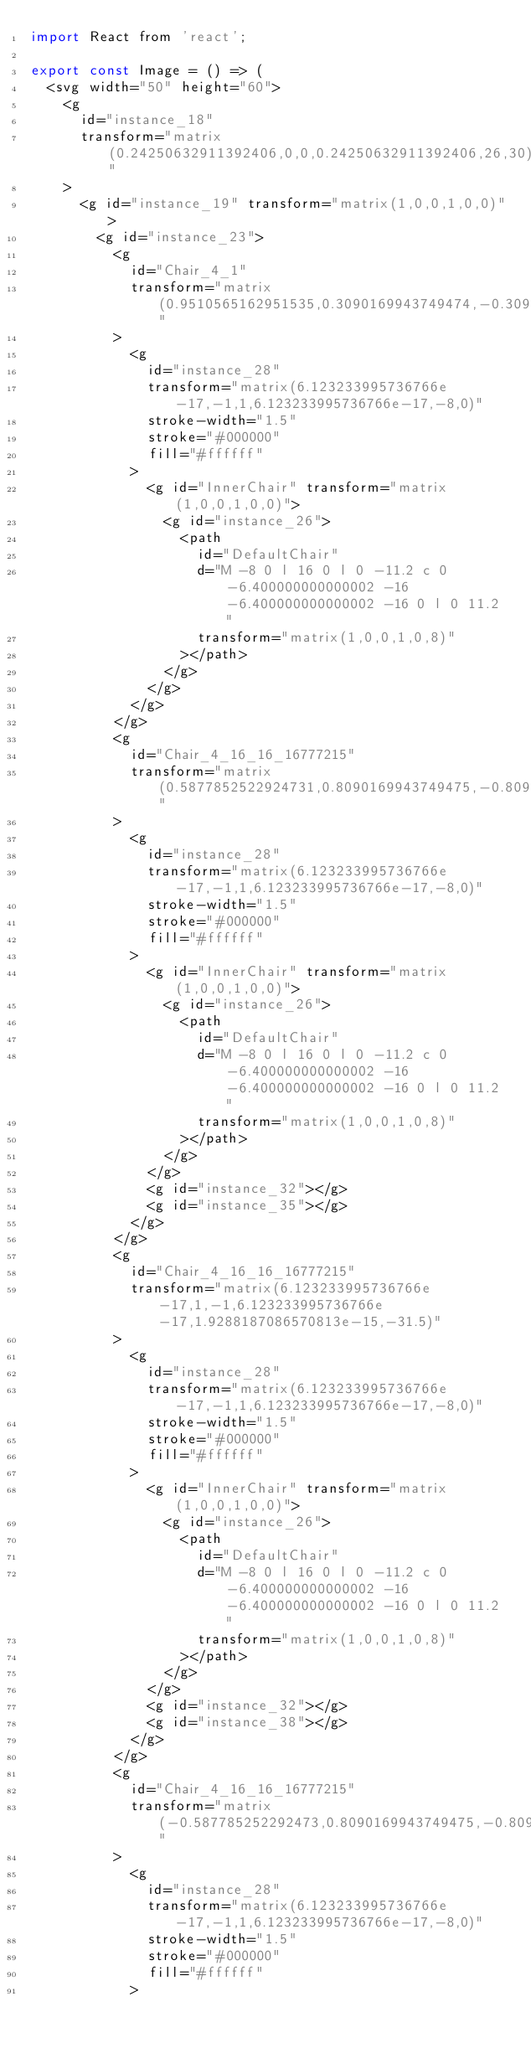Convert code to text. <code><loc_0><loc_0><loc_500><loc_500><_JavaScript_>import React from 'react';

export const Image = () => (
  <svg width="50" height="60">
    <g
      id="instance_18"
      transform="matrix(0.24250632911392406,0,0,0.24250632911392406,26,30)"
    >
      <g id="instance_19" transform="matrix(1,0,0,1,0,0)">
        <g id="instance_23">
          <g
            id="Chair_4_1"
            transform="matrix(0.9510565162951535,0.3090169943749474,-0.3090169943749474,0.9510565162951535,-29.958280263297336,-9.734035322810847)"
          >
            <g
              id="instance_28"
              transform="matrix(6.123233995736766e-17,-1,1,6.123233995736766e-17,-8,0)"
              stroke-width="1.5"
              stroke="#000000"
              fill="#ffffff"
            >
              <g id="InnerChair" transform="matrix(1,0,0,1,0,0)">
                <g id="instance_26">
                  <path
                    id="DefaultChair"
                    d="M -8 0 l 16 0 l 0 -11.2 c 0 -6.400000000000002 -16 -6.400000000000002 -16 0 l 0 11.2 "
                    transform="matrix(1,0,0,1,0,8)"
                  ></path>
                </g>
              </g>
            </g>
          </g>
          <g
            id="Chair_4_16_16_16777215"
            transform="matrix(0.5877852522924731,0.8090169943749475,-0.8090169943749475,0.5877852522924731,-18.515235447212902,-25.484035322810843)"
          >
            <g
              id="instance_28"
              transform="matrix(6.123233995736766e-17,-1,1,6.123233995736766e-17,-8,0)"
              stroke-width="1.5"
              stroke="#000000"
              fill="#ffffff"
            >
              <g id="InnerChair" transform="matrix(1,0,0,1,0,0)">
                <g id="instance_26">
                  <path
                    id="DefaultChair"
                    d="M -8 0 l 16 0 l 0 -11.2 c 0 -6.400000000000002 -16 -6.400000000000002 -16 0 l 0 11.2 "
                    transform="matrix(1,0,0,1,0,8)"
                  ></path>
                </g>
              </g>
              <g id="instance_32"></g>
              <g id="instance_35"></g>
            </g>
          </g>
          <g
            id="Chair_4_16_16_16777215"
            transform="matrix(6.123233995736766e-17,1,-1,6.123233995736766e-17,1.9288187086570813e-15,-31.5)"
          >
            <g
              id="instance_28"
              transform="matrix(6.123233995736766e-17,-1,1,6.123233995736766e-17,-8,0)"
              stroke-width="1.5"
              stroke="#000000"
              fill="#ffffff"
            >
              <g id="InnerChair" transform="matrix(1,0,0,1,0,0)">
                <g id="instance_26">
                  <path
                    id="DefaultChair"
                    d="M -8 0 l 16 0 l 0 -11.2 c 0 -6.400000000000002 -16 -6.400000000000002 -16 0 l 0 11.2 "
                    transform="matrix(1,0,0,1,0,8)"
                  ></path>
                </g>
              </g>
              <g id="instance_32"></g>
              <g id="instance_38"></g>
            </g>
          </g>
          <g
            id="Chair_4_16_16_16777215"
            transform="matrix(-0.587785252292473,0.8090169943749475,-0.8090169943749475,-0.587785252292473,18.515235447212905,-25.484035322810843)"
          >
            <g
              id="instance_28"
              transform="matrix(6.123233995736766e-17,-1,1,6.123233995736766e-17,-8,0)"
              stroke-width="1.5"
              stroke="#000000"
              fill="#ffffff"
            ></code> 